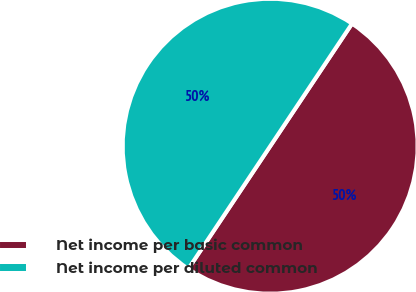Convert chart to OTSL. <chart><loc_0><loc_0><loc_500><loc_500><pie_chart><fcel>Net income per basic common<fcel>Net income per diluted common<nl><fcel>50.0%<fcel>50.0%<nl></chart> 